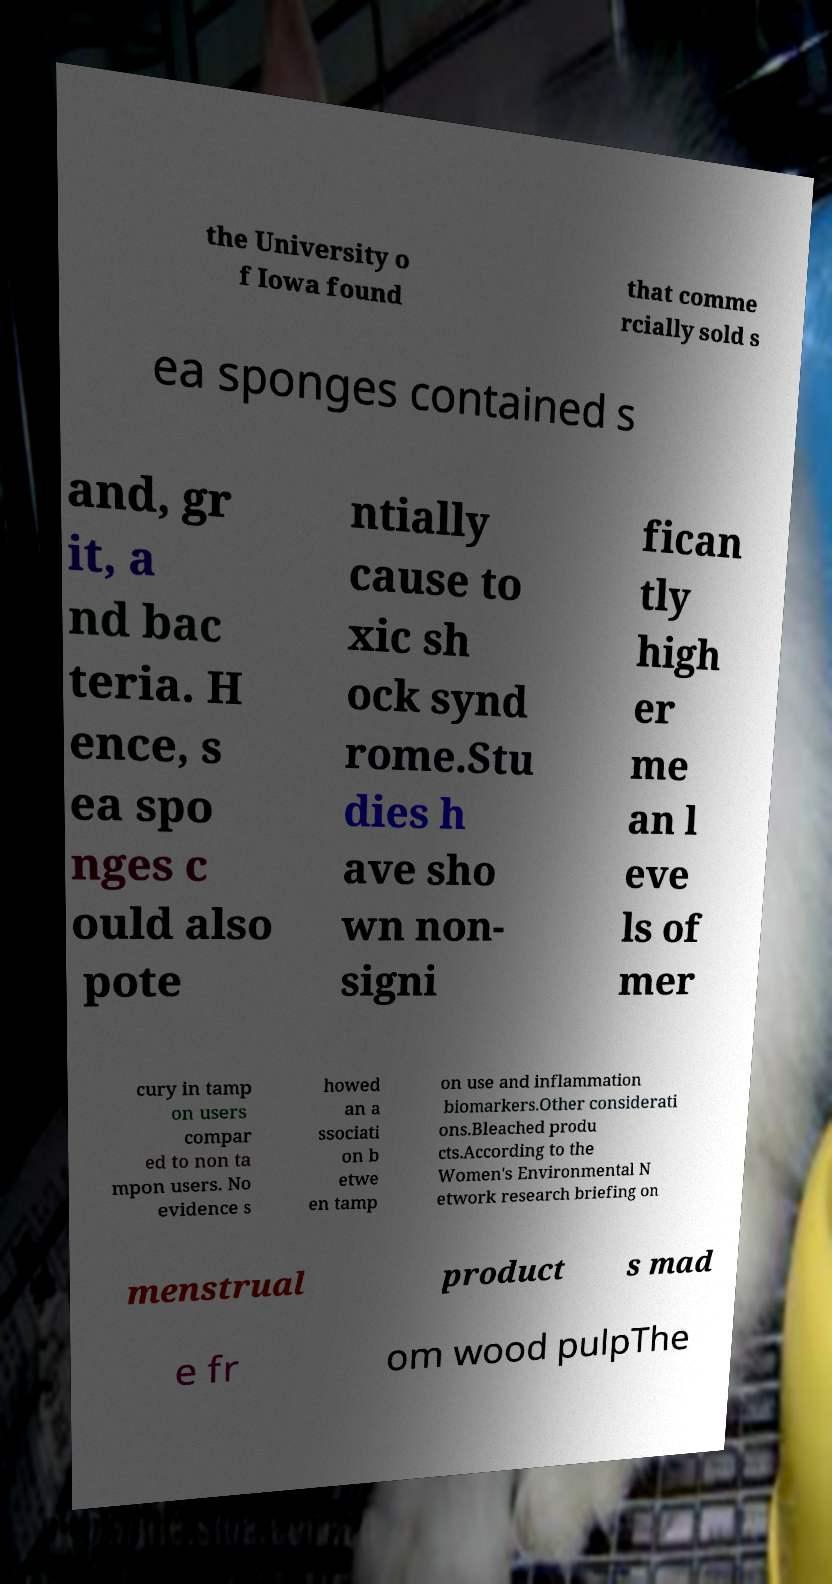Please read and relay the text visible in this image. What does it say? the University o f Iowa found that comme rcially sold s ea sponges contained s and, gr it, a nd bac teria. H ence, s ea spo nges c ould also pote ntially cause to xic sh ock synd rome.Stu dies h ave sho wn non- signi fican tly high er me an l eve ls of mer cury in tamp on users compar ed to non ta mpon users. No evidence s howed an a ssociati on b etwe en tamp on use and inflammation biomarkers.Other considerati ons.Bleached produ cts.According to the Women's Environmental N etwork research briefing on menstrual product s mad e fr om wood pulpThe 